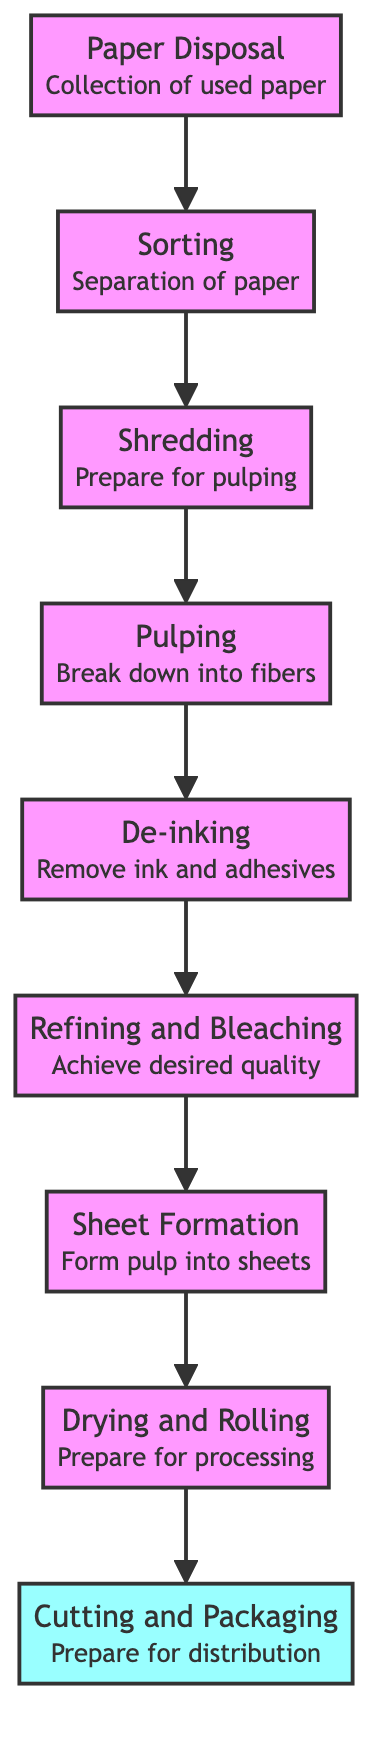What is the topmost step in the recycling process? The topmost step is Cutting and Packaging, which is the final stage in the process before the product is distributed. It can be confirmed by checking the position of the nodes in the flowchart.
Answer: Cutting and Packaging How many steps are involved in the recycling process? There are a total of 8 steps involved in the recycling process, which can be counted by listing all the nodes in the flowchart from Paper Disposal to Cutting and Packaging.
Answer: 8 Which step occurs after Drying and Rolling? The step that occurs after Drying and Rolling is Cutting and Packaging. This can be determined by following the arrows in the flowchart from the Drying and Rolling node to the next node.
Answer: Cutting and Packaging What is the purpose of the Pulping step? The purpose of the Pulping step is to break down shredded paper into fibers. This information is provided in the description associated with the Pulping node.
Answer: Break down into fibers How does the Sorting step relate to Paper Disposal? The Sorting step directly follows Paper Disposal, indicating that it is the first step taken after paper is collected from disposal. This relationship can be observed through the flow direction indicated by the arrows.
Answer: It follows Paper Disposal What is the main action performed during the De-inking step? The main action performed during the De-inking step is removing ink and adhesives from the pulp. This is explicitly stated in the description of the De-inking node in the flowchart.
Answer: Remove ink and adhesives Which step comes before Refining and Bleaching? The step that comes before Refining and Bleaching is De-inking, as indicated by the connection between those two nodes in the flowchart.
Answer: De-inking What type of materials are separated in the Sorting step? In the Sorting step, materials separated are contaminants like plastics, metals, and other non-paper materials, as described in the Sorting node of the flowchart.
Answer: Contaminants 